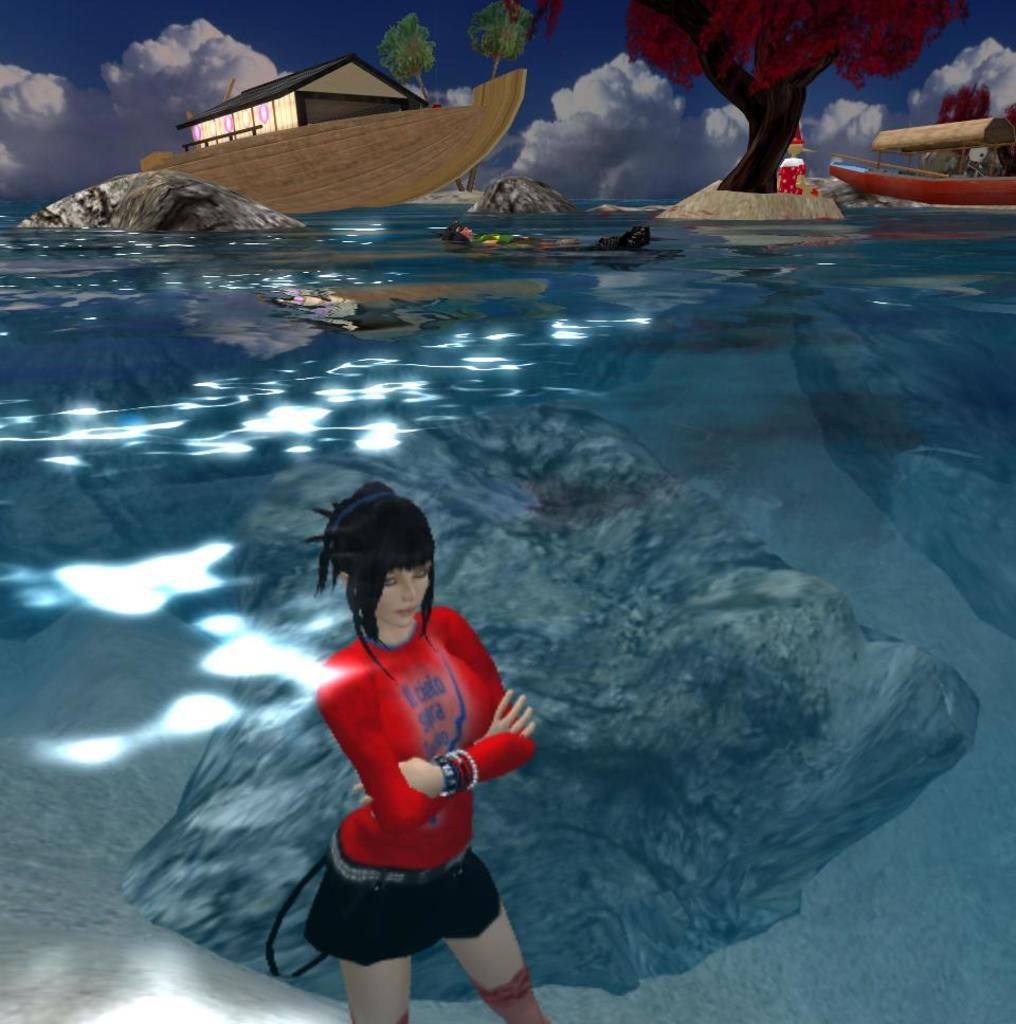What type of scene is depicted in the image? The image contains an animated scene. Can you describe any characters in the image? There is a woman in the image. What mode of transportation is present in the image? There is a boat in the image. What is unique about the boat in the image? The boat contains a house. What type of natural environment is visible in the image? Trees are present in the image. What part of the natural environment is visible in the image? The sky is visible in the image. What body of water is present in the image? There is water visible in the image. What type of snail can be seen crawling on the woman's shoulder in the image? There is no snail present on the woman's shoulder in the image. What type of prison can be seen in the background of the image? There is no prison present in the image; it features an animated scene with a woman, a boat, and a house. 